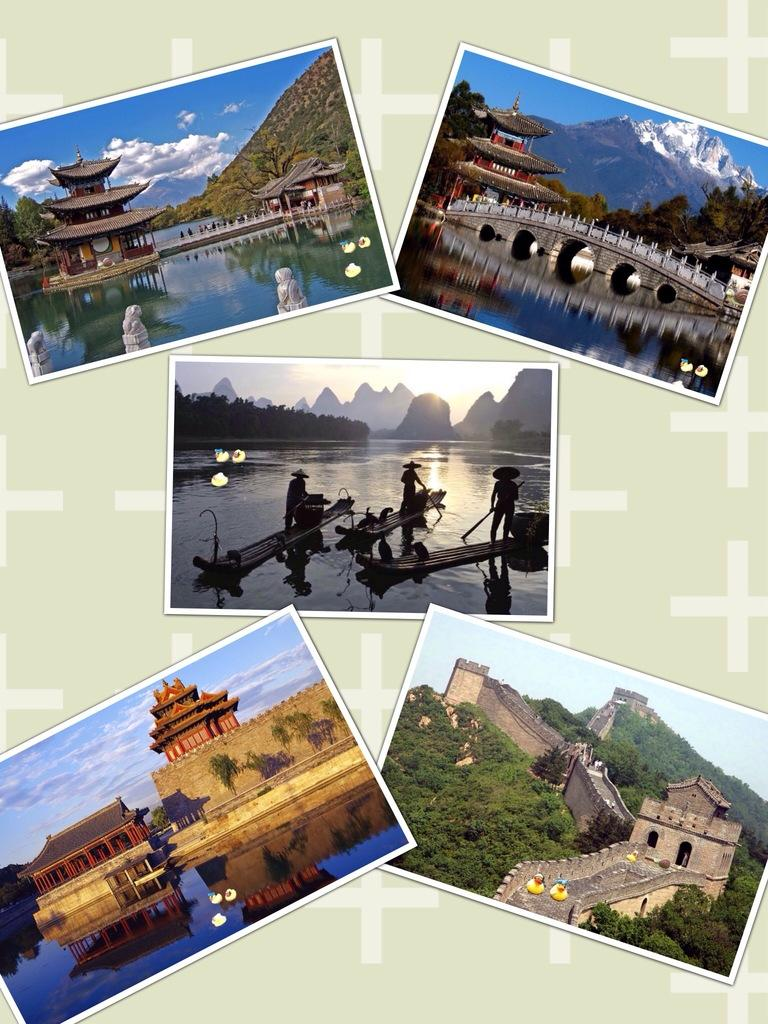What type of artwork is depicted in the image? The image is a collage. What structures can be seen in the collage? There are houses and a bridge in the collage. What type of transportation is present in the collage? There are boats in the collage. What type of vegetation is present in the collage? There are trees in the collage. What part of the natural environment is visible in the collage? The sky is visible in the collage. How many guns are visible in the collage? There are no guns present in the collage. Can you compare the size of the houses in the collage to the size of the trees? The provided facts do not include information about the size of the houses or trees, so it is not possible to make a comparison. 